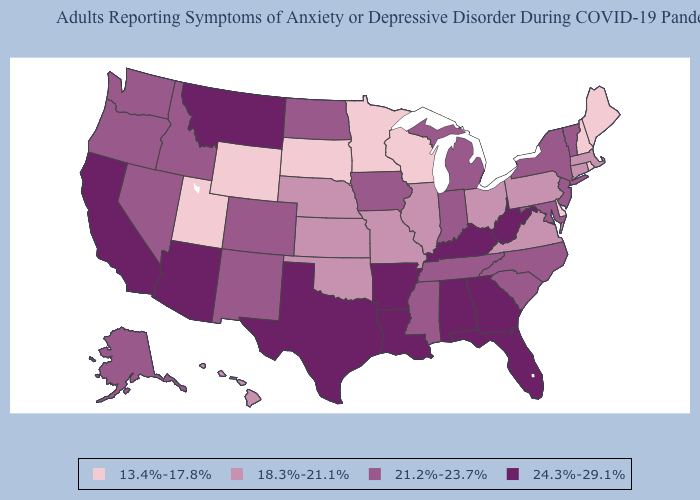Does Wisconsin have the lowest value in the USA?
Keep it brief. Yes. Among the states that border New Mexico , does Arizona have the highest value?
Short answer required. Yes. Among the states that border Utah , which have the lowest value?
Short answer required. Wyoming. Among the states that border Kansas , does Nebraska have the highest value?
Short answer required. No. Does Arizona have the highest value in the West?
Give a very brief answer. Yes. Name the states that have a value in the range 18.3%-21.1%?
Quick response, please. Connecticut, Hawaii, Illinois, Kansas, Massachusetts, Missouri, Nebraska, Ohio, Oklahoma, Pennsylvania, Virginia. What is the highest value in the South ?
Keep it brief. 24.3%-29.1%. Among the states that border Illinois , which have the lowest value?
Concise answer only. Wisconsin. What is the highest value in states that border Florida?
Quick response, please. 24.3%-29.1%. Name the states that have a value in the range 13.4%-17.8%?
Quick response, please. Delaware, Maine, Minnesota, New Hampshire, Rhode Island, South Dakota, Utah, Wisconsin, Wyoming. Among the states that border Missouri , does Kentucky have the highest value?
Write a very short answer. Yes. Name the states that have a value in the range 21.2%-23.7%?
Be succinct. Alaska, Colorado, Idaho, Indiana, Iowa, Maryland, Michigan, Mississippi, Nevada, New Jersey, New Mexico, New York, North Carolina, North Dakota, Oregon, South Carolina, Tennessee, Vermont, Washington. Does the map have missing data?
Be succinct. No. Among the states that border Alabama , does Florida have the lowest value?
Quick response, please. No. 